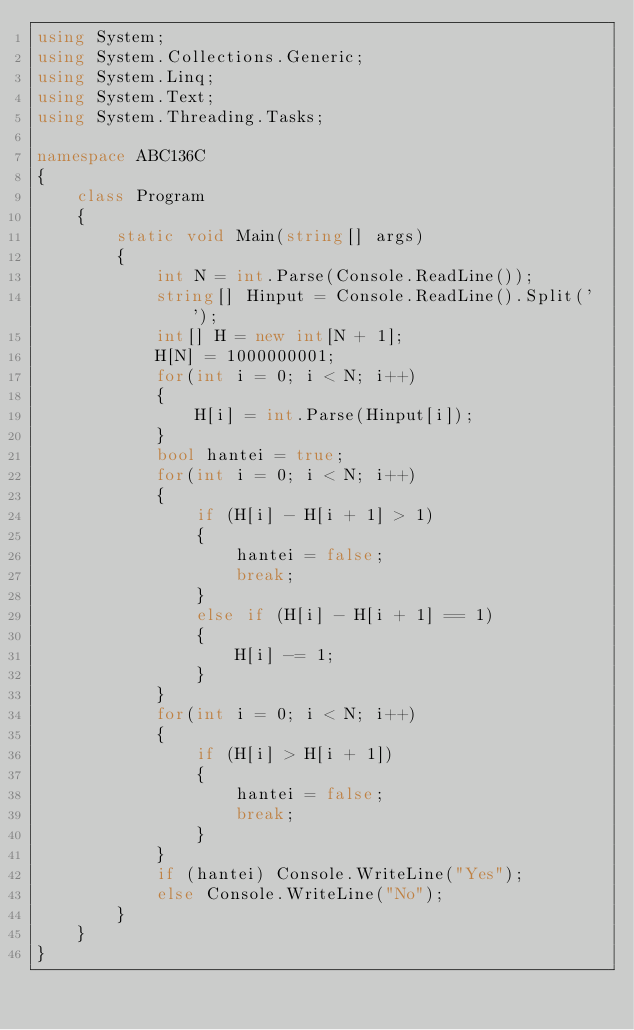Convert code to text. <code><loc_0><loc_0><loc_500><loc_500><_C#_>using System;
using System.Collections.Generic;
using System.Linq;
using System.Text;
using System.Threading.Tasks;

namespace ABC136C
{
    class Program
    {
        static void Main(string[] args)
        {
            int N = int.Parse(Console.ReadLine());
            string[] Hinput = Console.ReadLine().Split(' ');
            int[] H = new int[N + 1];
            H[N] = 1000000001;
            for(int i = 0; i < N; i++)
            {
                H[i] = int.Parse(Hinput[i]);
            }
            bool hantei = true;
            for(int i = 0; i < N; i++)
            {
                if (H[i] - H[i + 1] > 1)
                {
                    hantei = false;
                    break;
                }
                else if (H[i] - H[i + 1] == 1)
                {
                    H[i] -= 1;
                }
            }
            for(int i = 0; i < N; i++)
            {
                if (H[i] > H[i + 1])
                {
                    hantei = false;
                    break;
                }
            }
            if (hantei) Console.WriteLine("Yes");
            else Console.WriteLine("No");
        }
    }
}
</code> 